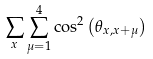Convert formula to latex. <formula><loc_0><loc_0><loc_500><loc_500>\sum _ { x } \sum _ { \mu = 1 } ^ { 4 } \cos ^ { 2 } \left ( \theta _ { x , x + \mu } \right )</formula> 